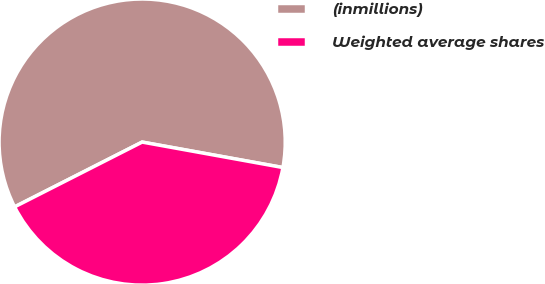Convert chart. <chart><loc_0><loc_0><loc_500><loc_500><pie_chart><fcel>(inmillions)<fcel>Weighted average shares<nl><fcel>60.33%<fcel>39.67%<nl></chart> 